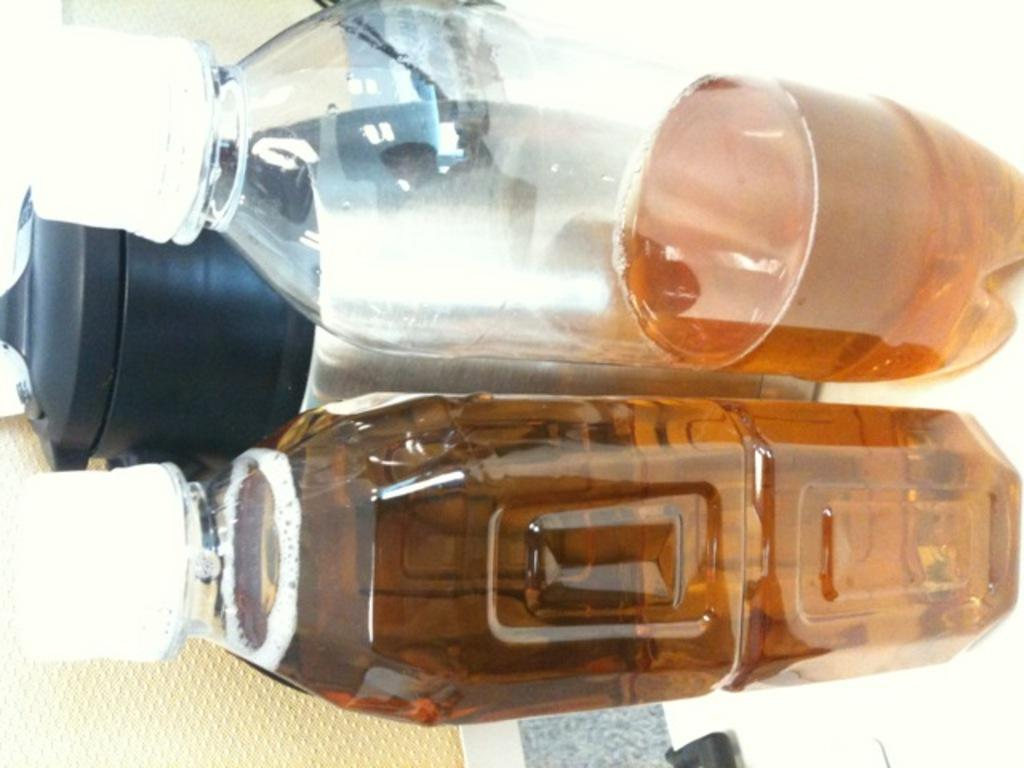How many bottles are visible in the image? There are three bottles in the image. How are the bottles arranged? The bottles are arranged horizontally. What can be found inside each bottle? Each bottle contains a different type of liquid. How many eggs are being attempted to be cracked by the giants in the image? There are no giants or eggs present in the image. 